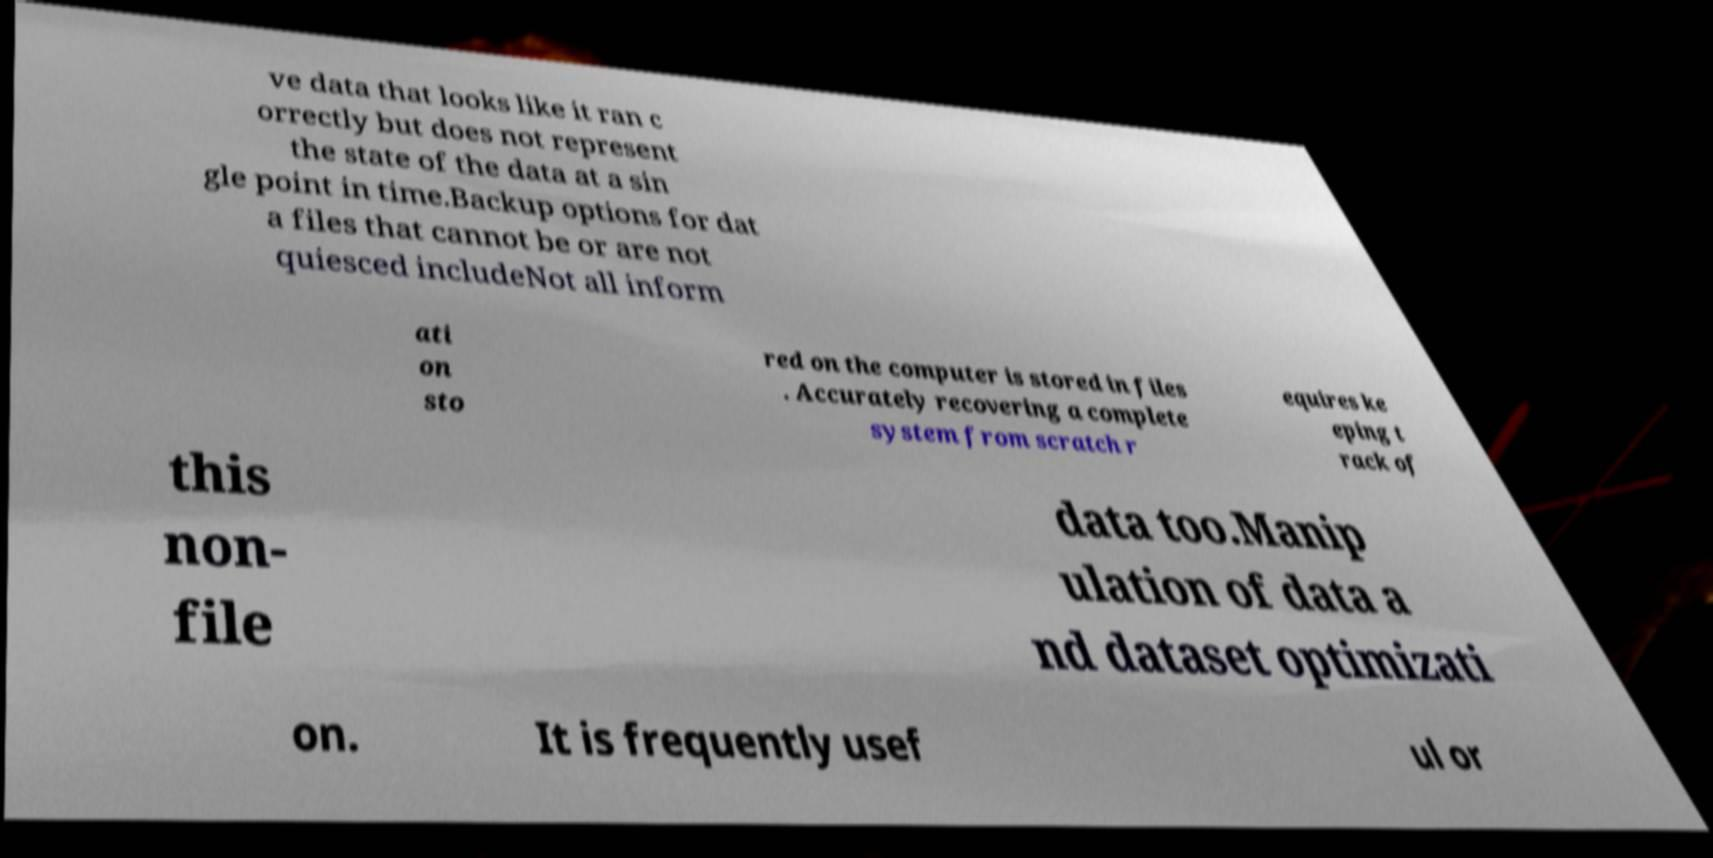Can you accurately transcribe the text from the provided image for me? ve data that looks like it ran c orrectly but does not represent the state of the data at a sin gle point in time.Backup options for dat a files that cannot be or are not quiesced includeNot all inform ati on sto red on the computer is stored in files . Accurately recovering a complete system from scratch r equires ke eping t rack of this non- file data too.Manip ulation of data a nd dataset optimizati on. It is frequently usef ul or 